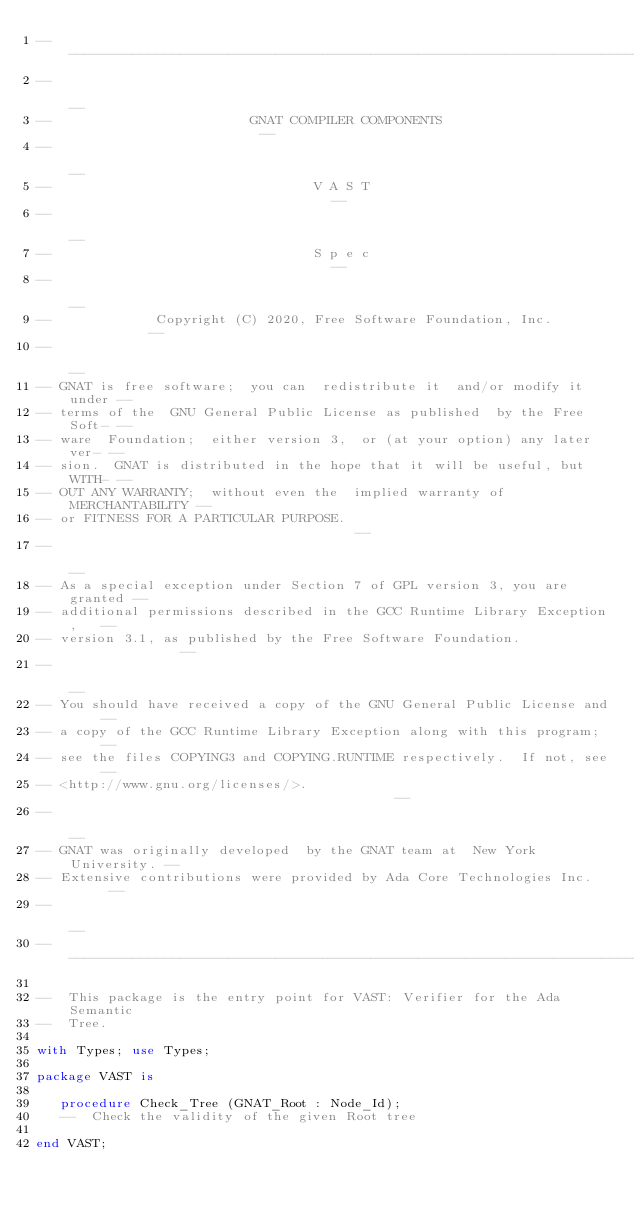Convert code to text. <code><loc_0><loc_0><loc_500><loc_500><_Ada_>------------------------------------------------------------------------------
--                                                                          --
--                         GNAT COMPILER COMPONENTS                         --
--                                                                          --
--                                 V A S T                                  --
--                                                                          --
--                                 S p e c                                  --
--                                                                          --
--             Copyright (C) 2020, Free Software Foundation, Inc.           --
--                                                                          --
-- GNAT is free software;  you can  redistribute it  and/or modify it under --
-- terms of the  GNU General Public License as published  by the Free Soft- --
-- ware  Foundation;  either version 3,  or (at your option) any later ver- --
-- sion.  GNAT is distributed in the hope that it will be useful, but WITH- --
-- OUT ANY WARRANTY;  without even the  implied warranty of MERCHANTABILITY --
-- or FITNESS FOR A PARTICULAR PURPOSE.                                     --
--                                                                          --
-- As a special exception under Section 7 of GPL version 3, you are granted --
-- additional permissions described in the GCC Runtime Library Exception,   --
-- version 3.1, as published by the Free Software Foundation.               --
--                                                                          --
-- You should have received a copy of the GNU General Public License and    --
-- a copy of the GCC Runtime Library Exception along with this program;     --
-- see the files COPYING3 and COPYING.RUNTIME respectively.  If not, see    --
-- <http://www.gnu.org/licenses/>.                                          --
--                                                                          --
-- GNAT was originally developed  by the GNAT team at  New York University. --
-- Extensive contributions were provided by Ada Core Technologies Inc.      --
--                                                                          --
------------------------------------------------------------------------------

--  This package is the entry point for VAST: Verifier for the Ada Semantic
--  Tree.

with Types; use Types;

package VAST is

   procedure Check_Tree (GNAT_Root : Node_Id);
   --  Check the validity of the given Root tree

end VAST;
</code> 